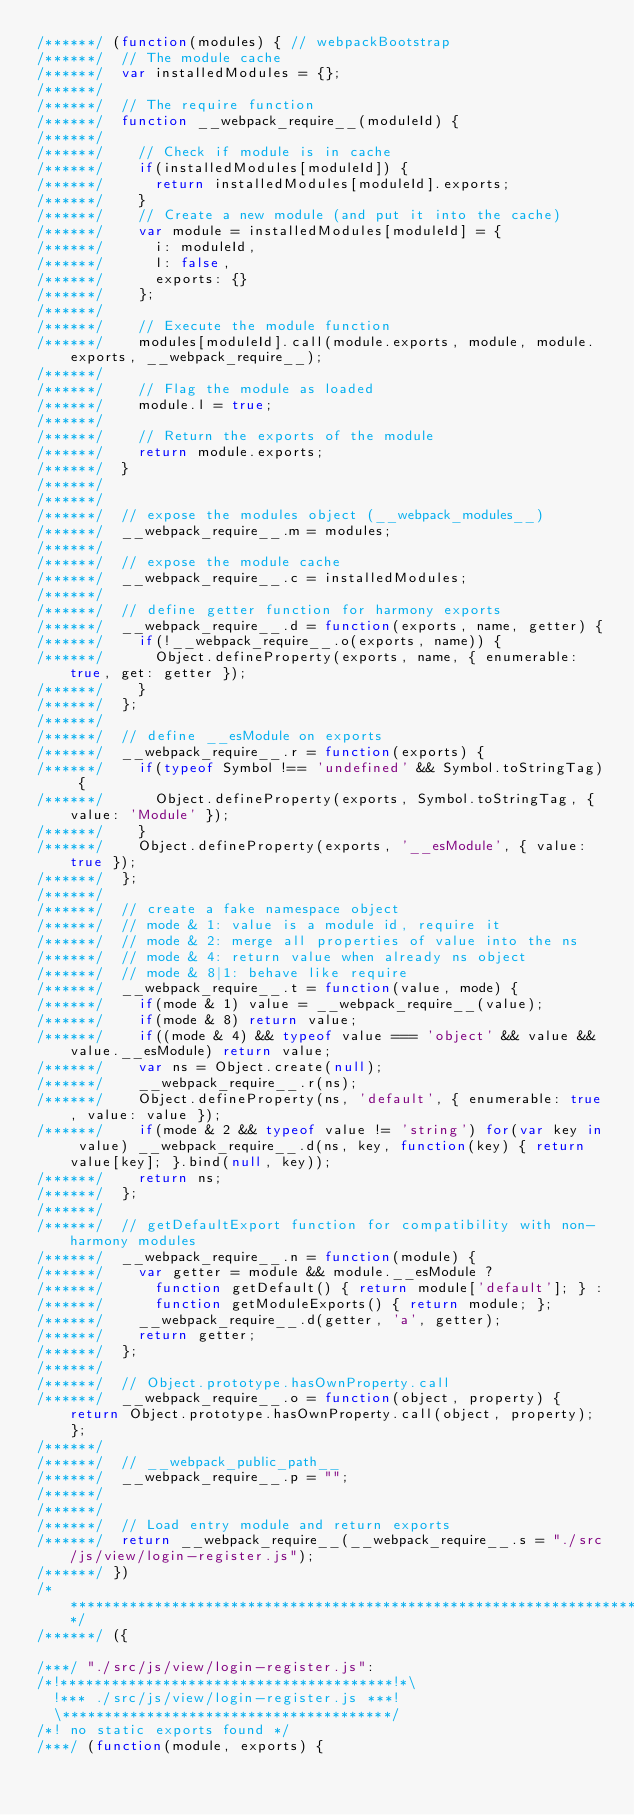<code> <loc_0><loc_0><loc_500><loc_500><_JavaScript_>/******/ (function(modules) { // webpackBootstrap
/******/ 	// The module cache
/******/ 	var installedModules = {};
/******/
/******/ 	// The require function
/******/ 	function __webpack_require__(moduleId) {
/******/
/******/ 		// Check if module is in cache
/******/ 		if(installedModules[moduleId]) {
/******/ 			return installedModules[moduleId].exports;
/******/ 		}
/******/ 		// Create a new module (and put it into the cache)
/******/ 		var module = installedModules[moduleId] = {
/******/ 			i: moduleId,
/******/ 			l: false,
/******/ 			exports: {}
/******/ 		};
/******/
/******/ 		// Execute the module function
/******/ 		modules[moduleId].call(module.exports, module, module.exports, __webpack_require__);
/******/
/******/ 		// Flag the module as loaded
/******/ 		module.l = true;
/******/
/******/ 		// Return the exports of the module
/******/ 		return module.exports;
/******/ 	}
/******/
/******/
/******/ 	// expose the modules object (__webpack_modules__)
/******/ 	__webpack_require__.m = modules;
/******/
/******/ 	// expose the module cache
/******/ 	__webpack_require__.c = installedModules;
/******/
/******/ 	// define getter function for harmony exports
/******/ 	__webpack_require__.d = function(exports, name, getter) {
/******/ 		if(!__webpack_require__.o(exports, name)) {
/******/ 			Object.defineProperty(exports, name, { enumerable: true, get: getter });
/******/ 		}
/******/ 	};
/******/
/******/ 	// define __esModule on exports
/******/ 	__webpack_require__.r = function(exports) {
/******/ 		if(typeof Symbol !== 'undefined' && Symbol.toStringTag) {
/******/ 			Object.defineProperty(exports, Symbol.toStringTag, { value: 'Module' });
/******/ 		}
/******/ 		Object.defineProperty(exports, '__esModule', { value: true });
/******/ 	};
/******/
/******/ 	// create a fake namespace object
/******/ 	// mode & 1: value is a module id, require it
/******/ 	// mode & 2: merge all properties of value into the ns
/******/ 	// mode & 4: return value when already ns object
/******/ 	// mode & 8|1: behave like require
/******/ 	__webpack_require__.t = function(value, mode) {
/******/ 		if(mode & 1) value = __webpack_require__(value);
/******/ 		if(mode & 8) return value;
/******/ 		if((mode & 4) && typeof value === 'object' && value && value.__esModule) return value;
/******/ 		var ns = Object.create(null);
/******/ 		__webpack_require__.r(ns);
/******/ 		Object.defineProperty(ns, 'default', { enumerable: true, value: value });
/******/ 		if(mode & 2 && typeof value != 'string') for(var key in value) __webpack_require__.d(ns, key, function(key) { return value[key]; }.bind(null, key));
/******/ 		return ns;
/******/ 	};
/******/
/******/ 	// getDefaultExport function for compatibility with non-harmony modules
/******/ 	__webpack_require__.n = function(module) {
/******/ 		var getter = module && module.__esModule ?
/******/ 			function getDefault() { return module['default']; } :
/******/ 			function getModuleExports() { return module; };
/******/ 		__webpack_require__.d(getter, 'a', getter);
/******/ 		return getter;
/******/ 	};
/******/
/******/ 	// Object.prototype.hasOwnProperty.call
/******/ 	__webpack_require__.o = function(object, property) { return Object.prototype.hasOwnProperty.call(object, property); };
/******/
/******/ 	// __webpack_public_path__
/******/ 	__webpack_require__.p = "";
/******/
/******/
/******/ 	// Load entry module and return exports
/******/ 	return __webpack_require__(__webpack_require__.s = "./src/js/view/login-register.js");
/******/ })
/************************************************************************/
/******/ ({

/***/ "./src/js/view/login-register.js":
/*!***************************************!*\
  !*** ./src/js/view/login-register.js ***!
  \***************************************/
/*! no static exports found */
/***/ (function(module, exports) {
</code> 